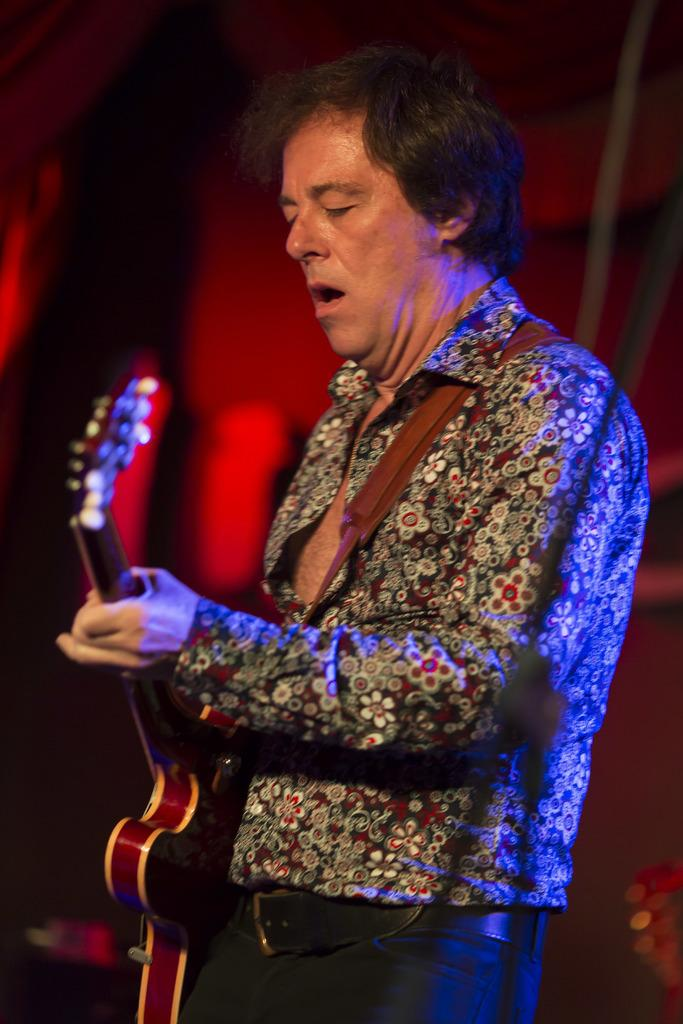What is the main subject of the image? There is a man in the image. What is the man doing in the image? The man is standing in the image. What object is the man holding in the image? The man is holding a guitar in his hand. What type of potato is the man holding in the image? There is no potato present in the image; the man is holding a guitar. How many roses can be seen in the image? There are no roses present in the image. 